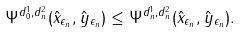Convert formula to latex. <formula><loc_0><loc_0><loc_500><loc_500>\Psi ^ { d ^ { 1 } _ { 0 } , d ^ { 2 } _ { n } } ( \hat { x } _ { \epsilon _ { n } } , \hat { y } _ { \epsilon _ { n } } ) \leq \Psi ^ { d ^ { 1 } _ { n } , d ^ { 2 } _ { n } } ( \hat { x } _ { \epsilon _ { n } } , \hat { y } _ { \epsilon _ { n } } ) .</formula> 